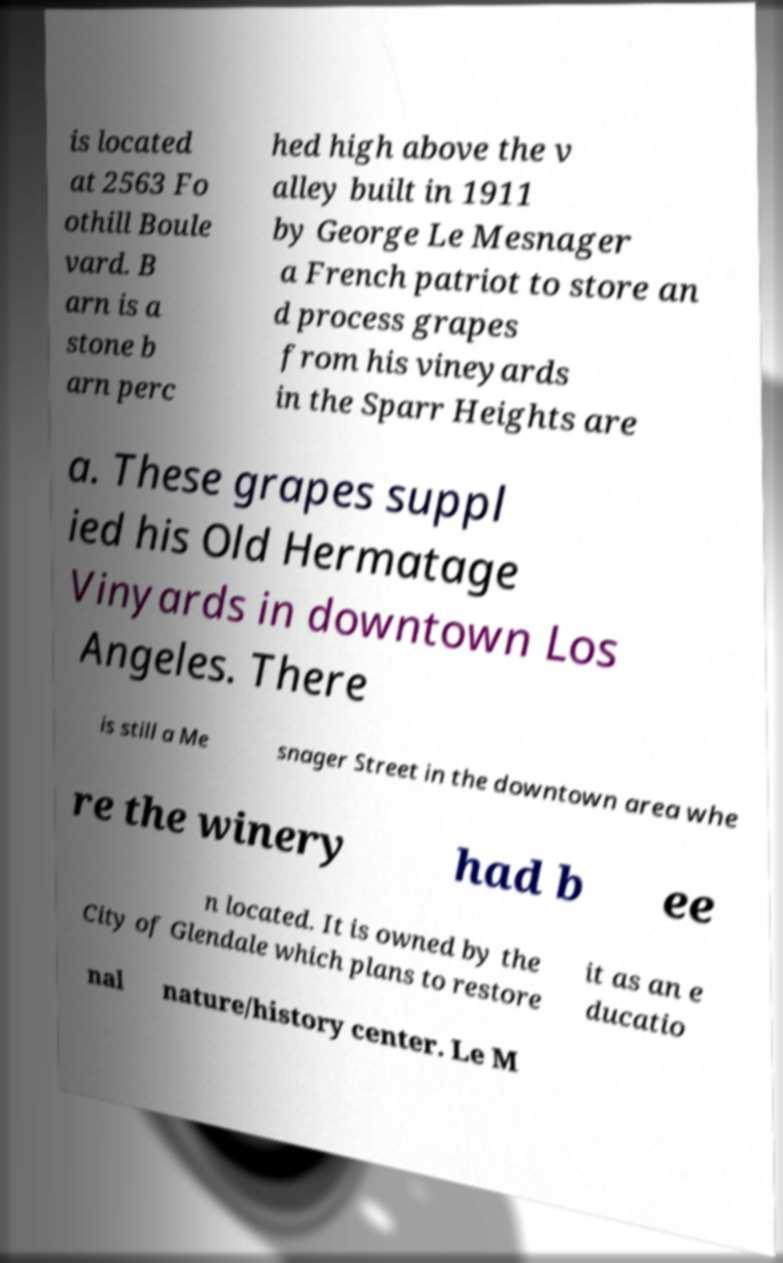There's text embedded in this image that I need extracted. Can you transcribe it verbatim? is located at 2563 Fo othill Boule vard. B arn is a stone b arn perc hed high above the v alley built in 1911 by George Le Mesnager a French patriot to store an d process grapes from his vineyards in the Sparr Heights are a. These grapes suppl ied his Old Hermatage Vinyards in downtown Los Angeles. There is still a Me snager Street in the downtown area whe re the winery had b ee n located. It is owned by the City of Glendale which plans to restore it as an e ducatio nal nature/history center. Le M 